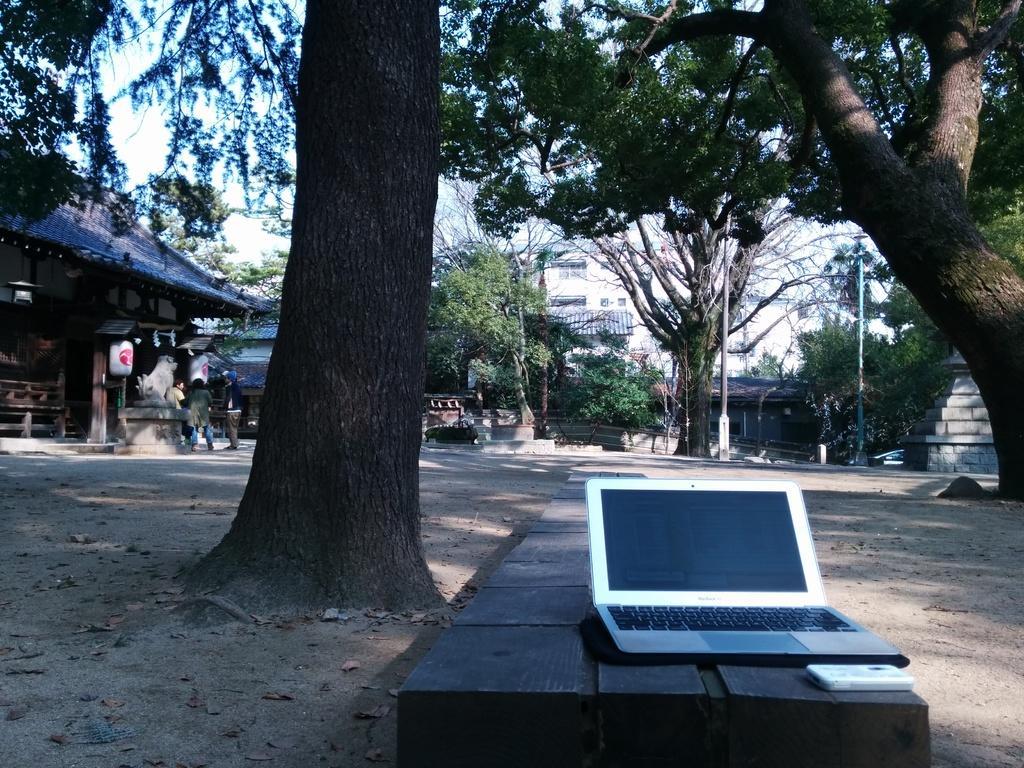How would you summarize this image in a sentence or two? In this image I can see a laptop. Background I can see few trees in green color, few persons standing, and sky in white color. 